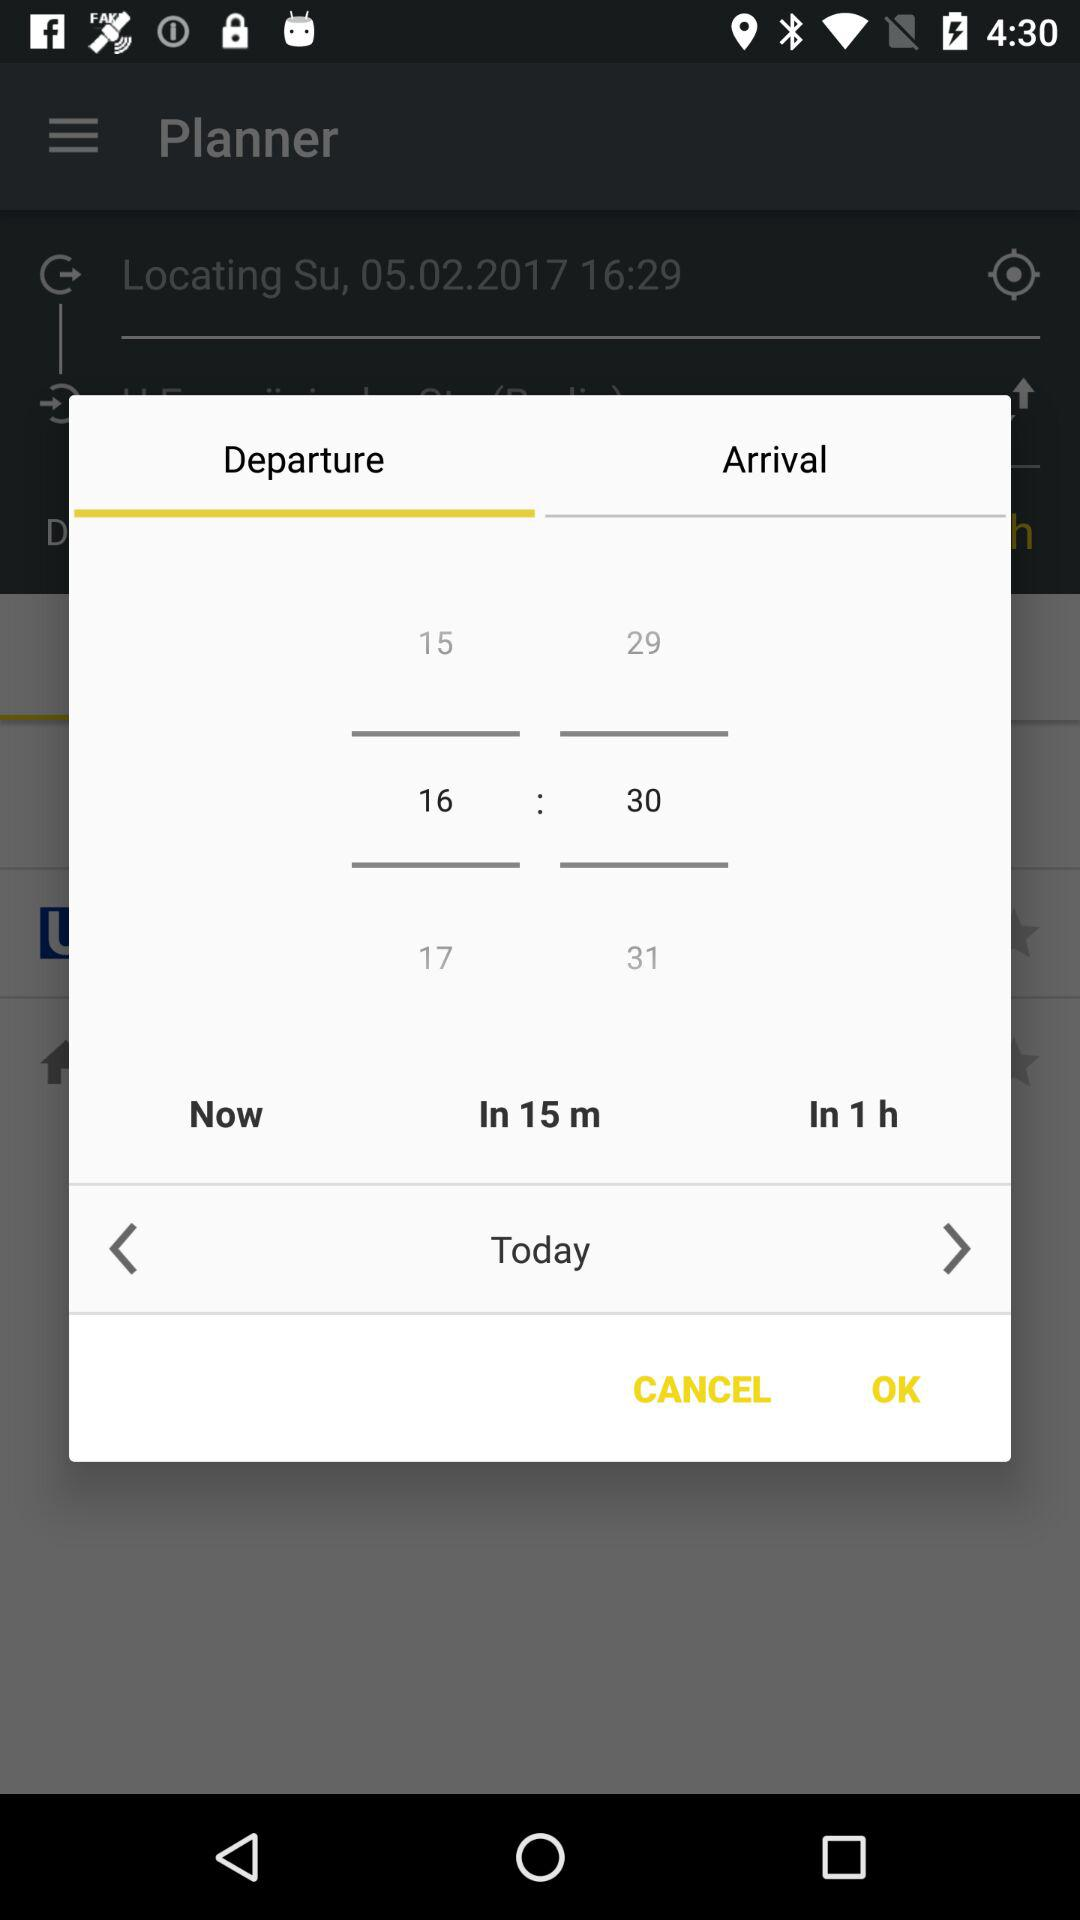What is the selected tab? The selected tab is "Departure". 